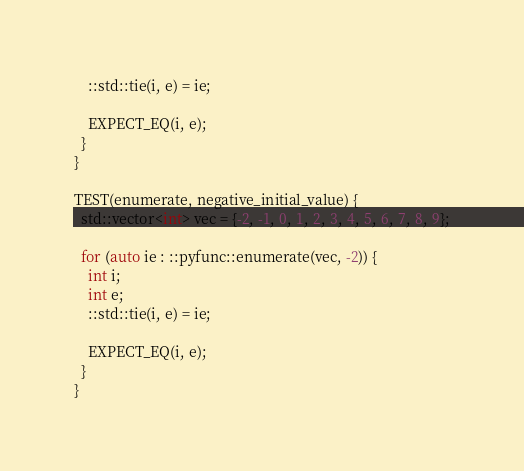<code> <loc_0><loc_0><loc_500><loc_500><_C++_>    ::std::tie(i, e) = ie;

    EXPECT_EQ(i, e);
  }
}

TEST(enumerate, negative_initial_value) {
  std::vector<int> vec = {-2, -1, 0, 1, 2, 3, 4, 5, 6, 7, 8, 9};

  for (auto ie : ::pyfunc::enumerate(vec, -2)) {
    int i;
    int e;
    ::std::tie(i, e) = ie;

    EXPECT_EQ(i, e);
  }
}
</code> 